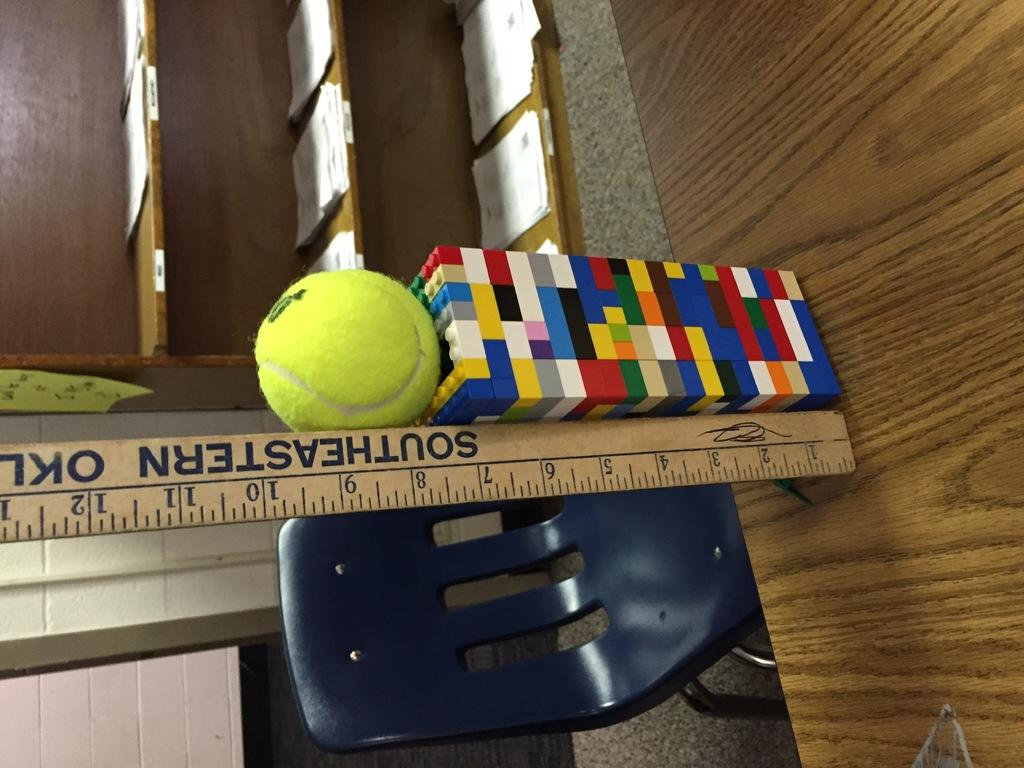What shapes are present in the image? There is a cube and a ball in the image. What object can be used to measure weight in the image? There is a scale in the image. What type of furniture is in the image? There is a chair in the image. What can be found on the shelves in the image? There are papers on the shelves in the image. What type of fruit is hanging from the cube in the image? There is no fruit present in the image, and the cube is not a structure that could support hanging fruit. 